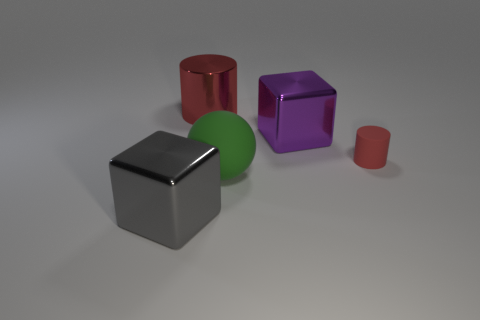Add 2 red shiny objects. How many objects exist? 7 Subtract all cylinders. How many objects are left? 3 Subtract all large purple shiny objects. Subtract all large red cylinders. How many objects are left? 3 Add 3 red objects. How many red objects are left? 5 Add 1 shiny things. How many shiny things exist? 4 Subtract 0 brown balls. How many objects are left? 5 